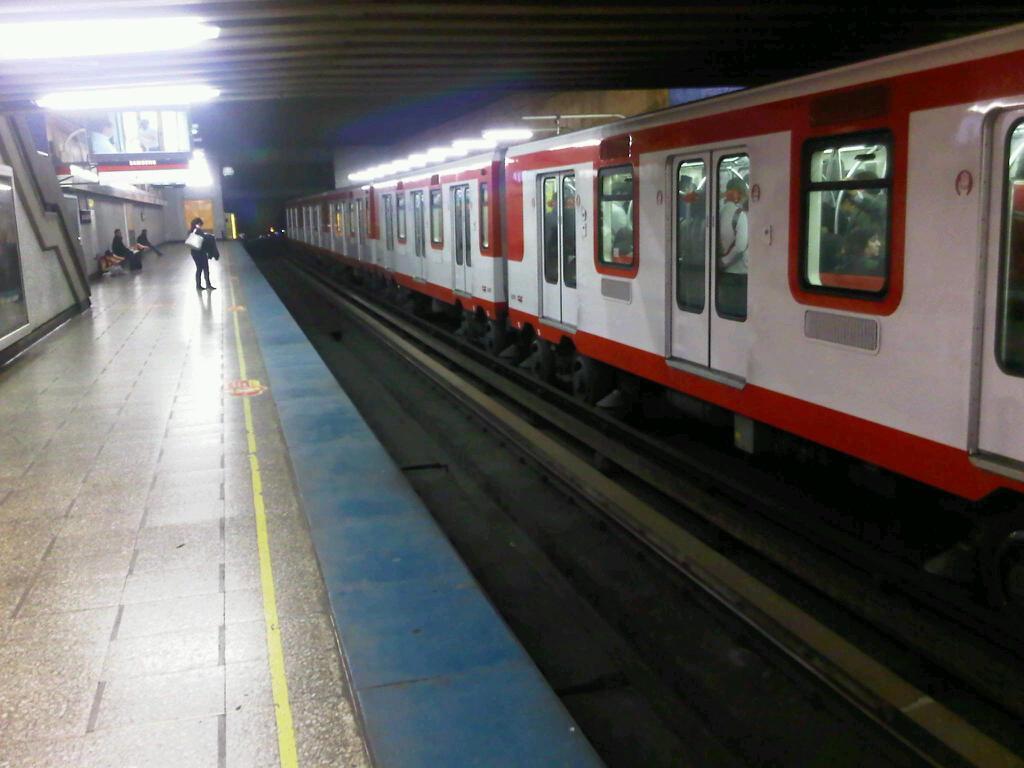How would you summarize this image in a sentence or two? On the right side there is a train with windows and doors. On the left side there is a platform. On that some people are there. Also there are lights on the ceiling. On the sides there are buildings. 